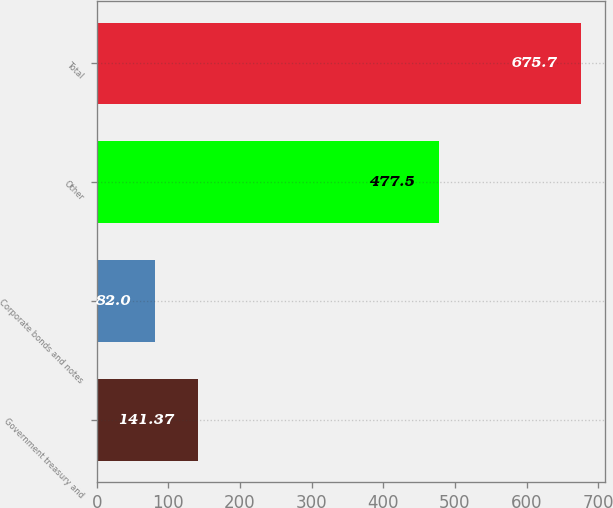<chart> <loc_0><loc_0><loc_500><loc_500><bar_chart><fcel>Government treasury and<fcel>Corporate bonds and notes<fcel>Other<fcel>Total<nl><fcel>141.37<fcel>82<fcel>477.5<fcel>675.7<nl></chart> 